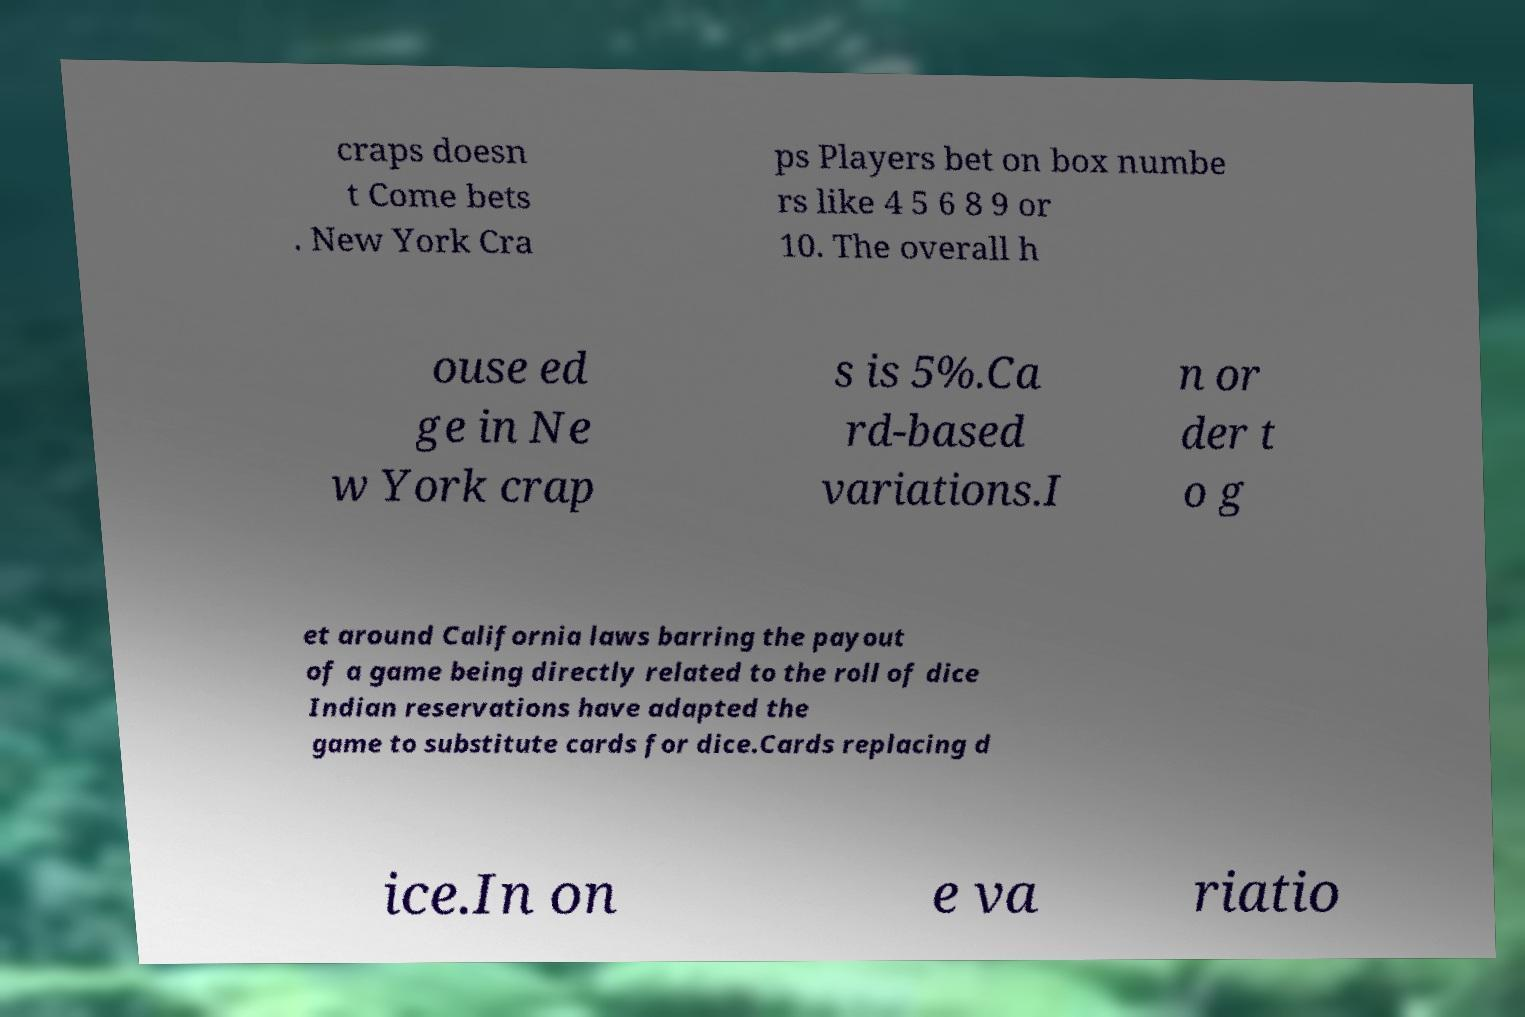Can you read and provide the text displayed in the image?This photo seems to have some interesting text. Can you extract and type it out for me? craps doesn t Come bets . New York Cra ps Players bet on box numbe rs like 4 5 6 8 9 or 10. The overall h ouse ed ge in Ne w York crap s is 5%.Ca rd-based variations.I n or der t o g et around California laws barring the payout of a game being directly related to the roll of dice Indian reservations have adapted the game to substitute cards for dice.Cards replacing d ice.In on e va riatio 